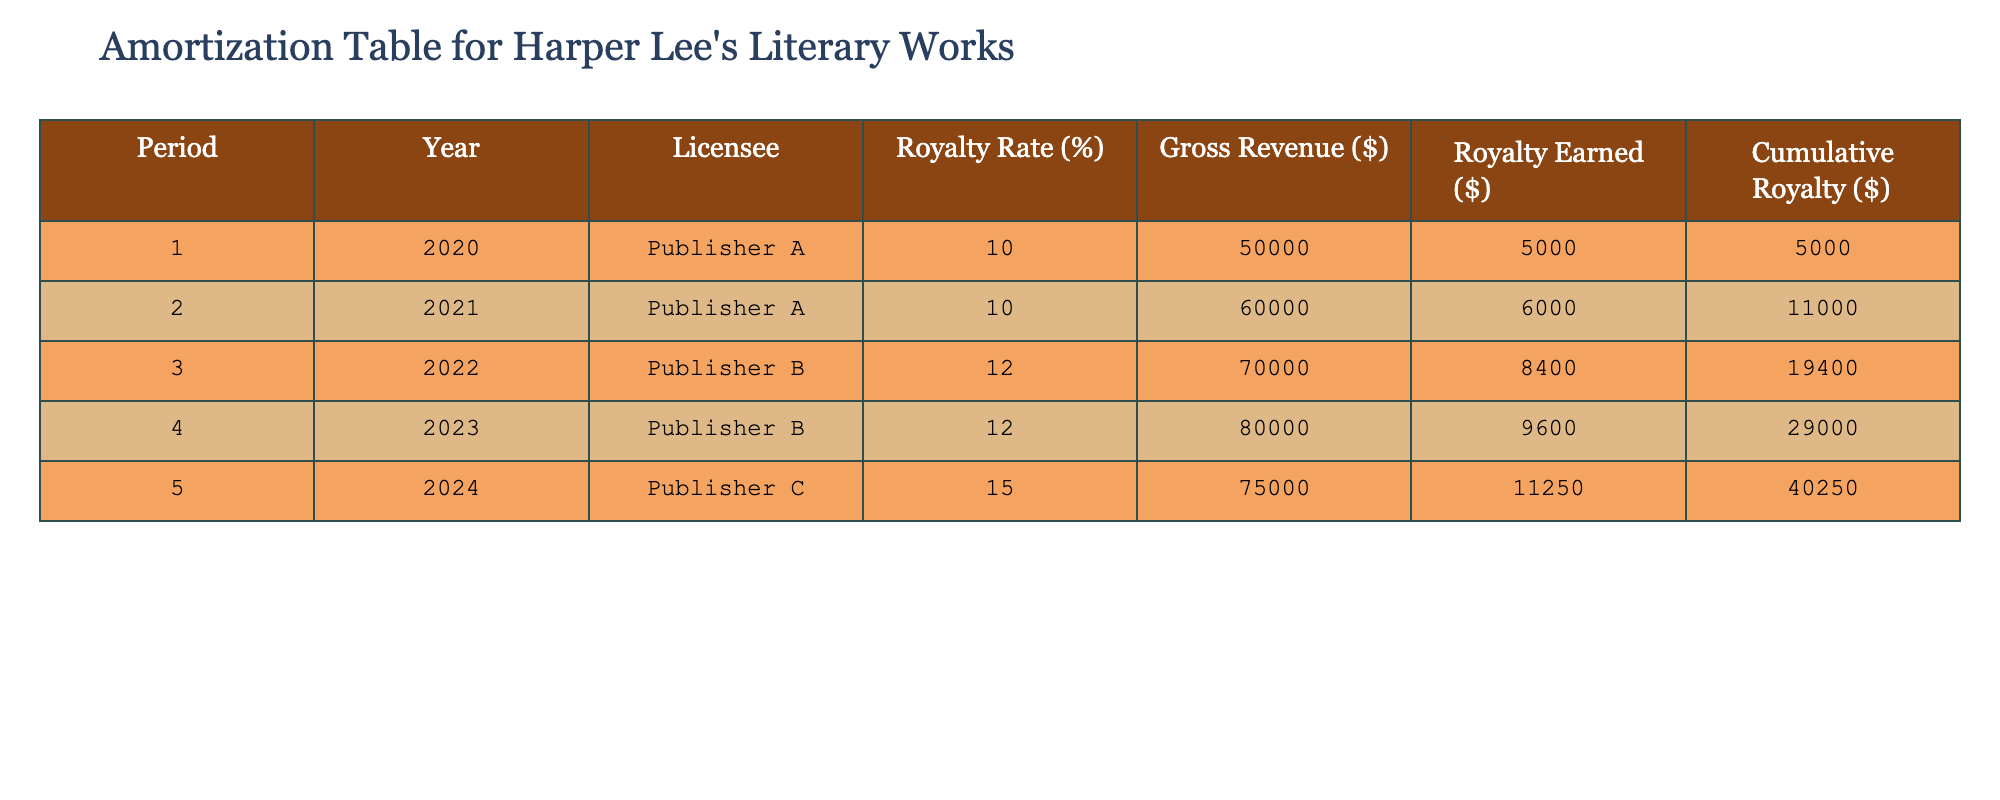What is the total royalty earned in 2022? In 2022, the royalty earned is listed as $8,400 in the table for Publisher B.
Answer: 8400 Which publisher had the highest royalty rate? Publisher C has the highest royalty rate at 15%, as specified in the table.
Answer: Publisher C What is the cumulative royalty earned by the end of 2024? The cumulative royalty at the end of 2024 is $40,250, as indicated in the table under the cumulative royalty column for period 5.
Answer: 40250 How much more royalty was earned in 2023 compared to 2020? In 2023, the royalty earned is $9,600, and in 2020, it was $5,000. The difference is $9,600 - $5,000 = $4,600.
Answer: 4600 True or false: The total gross revenue for 2021 was more than that for 2020. In the table, the gross revenue for 2021 is $60,000 while for 2020 it is $50,000, so 60,000 > 50,000 is true.
Answer: True What is the average royalty earned across all periods shown? The total royalty earned is $5,000 + $6,000 + $8,400 + $9,600 + $11,250 = $40,250. There are 5 periods, so the average is $40,250 / 5 = $8,050.
Answer: 8050 How much did Publisher B earn in royalties over the two years it was active? Publisher B earned $8,400 in 2022 and $9,600 in 2023, which adds up to $8,400 + $9,600 = $18,000.
Answer: 18000 Which year saw the lowest gross revenue? The year with the lowest gross revenue is 2020 with $50,000, as indicated in the table.
Answer: 2020 What is the percentage increase in gross revenue from 2021 to 2022? Gross revenue in 2021 is $60,000 and in 2022 it is $70,000. The percentage increase is calculated as (($70,000 - $60,000) / $60,000) * 100 = 16.67%.
Answer: 16.67% 